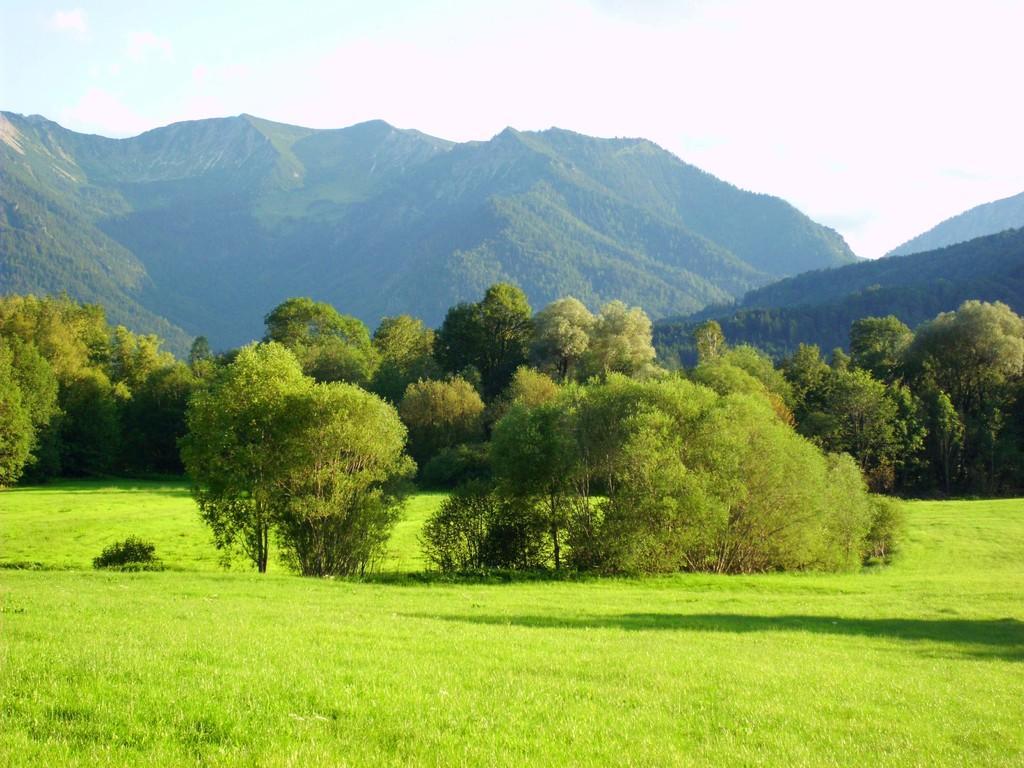Could you give a brief overview of what you see in this image? This image consists of many trees. At the bottom, there is green grass. In the background, there are mountains. At the top, there is sky. 